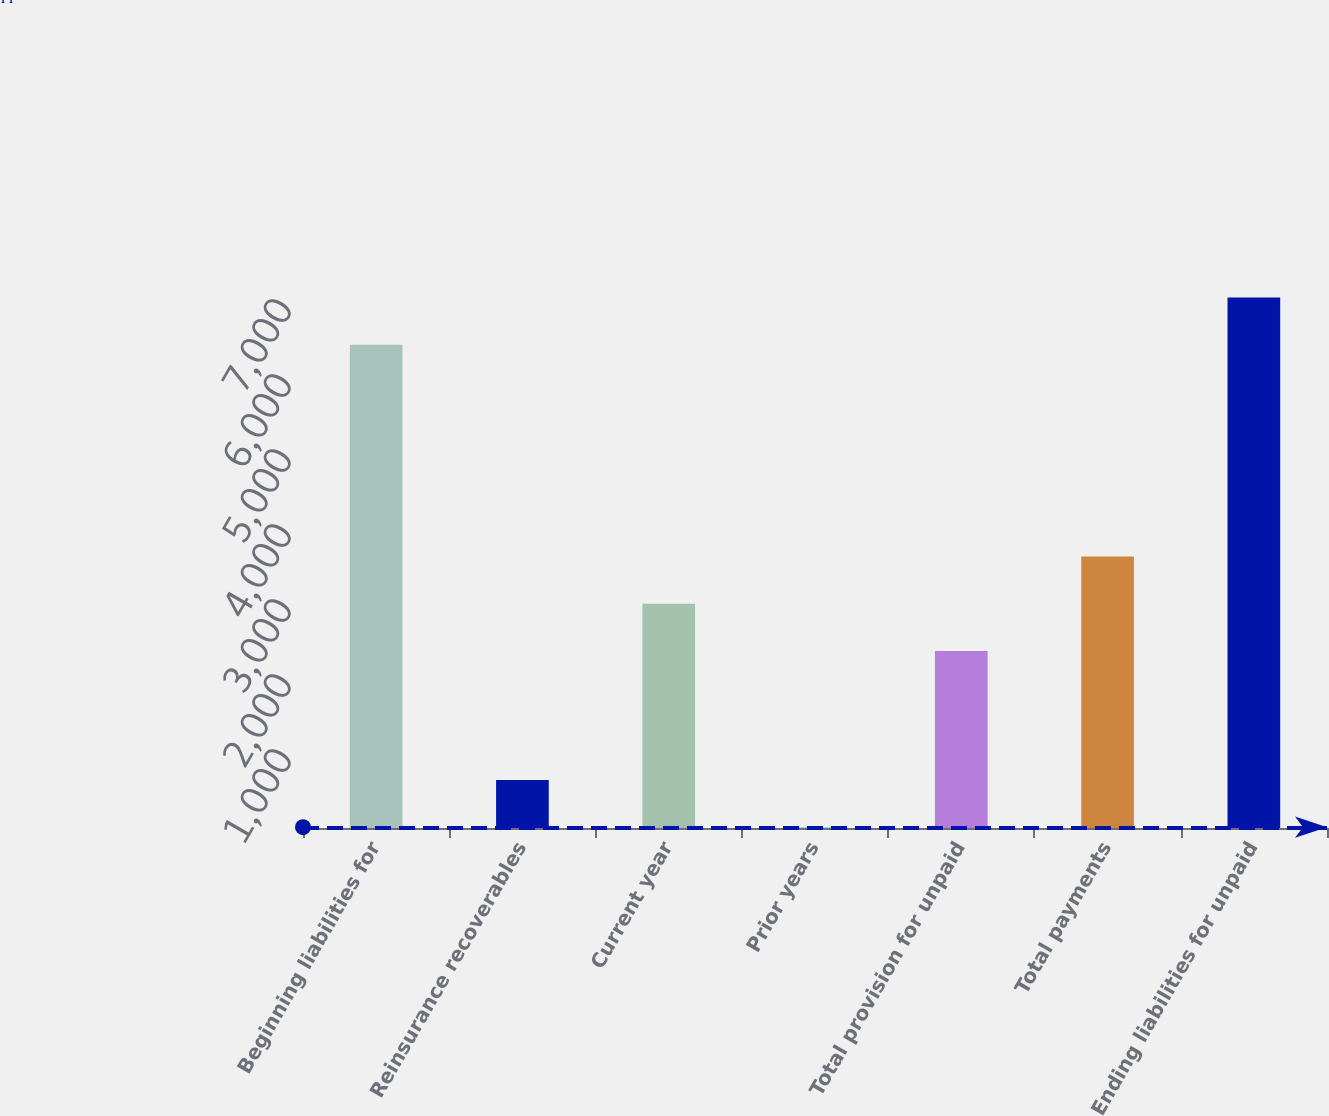Convert chart. <chart><loc_0><loc_0><loc_500><loc_500><bar_chart><fcel>Beginning liabilities for<fcel>Reinsurance recoverables<fcel>Current year<fcel>Prior years<fcel>Total provision for unpaid<fcel>Total payments<fcel>Ending liabilities for unpaid<nl><fcel>6442.7<fcel>640.7<fcel>2988.7<fcel>11<fcel>2359<fcel>3618.4<fcel>7072.4<nl></chart> 